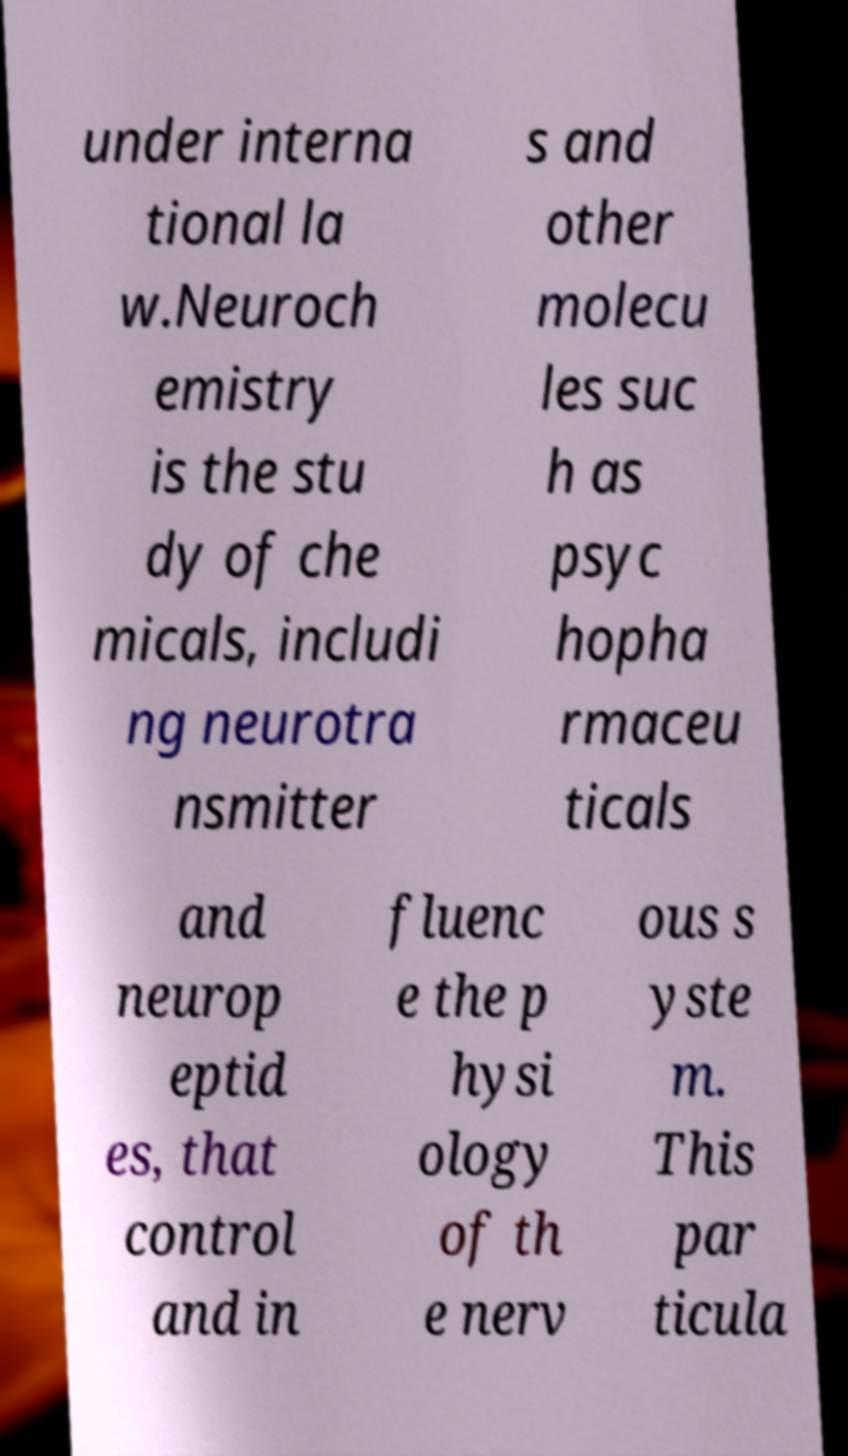Can you accurately transcribe the text from the provided image for me? under interna tional la w.Neuroch emistry is the stu dy of che micals, includi ng neurotra nsmitter s and other molecu les suc h as psyc hopha rmaceu ticals and neurop eptid es, that control and in fluenc e the p hysi ology of th e nerv ous s yste m. This par ticula 